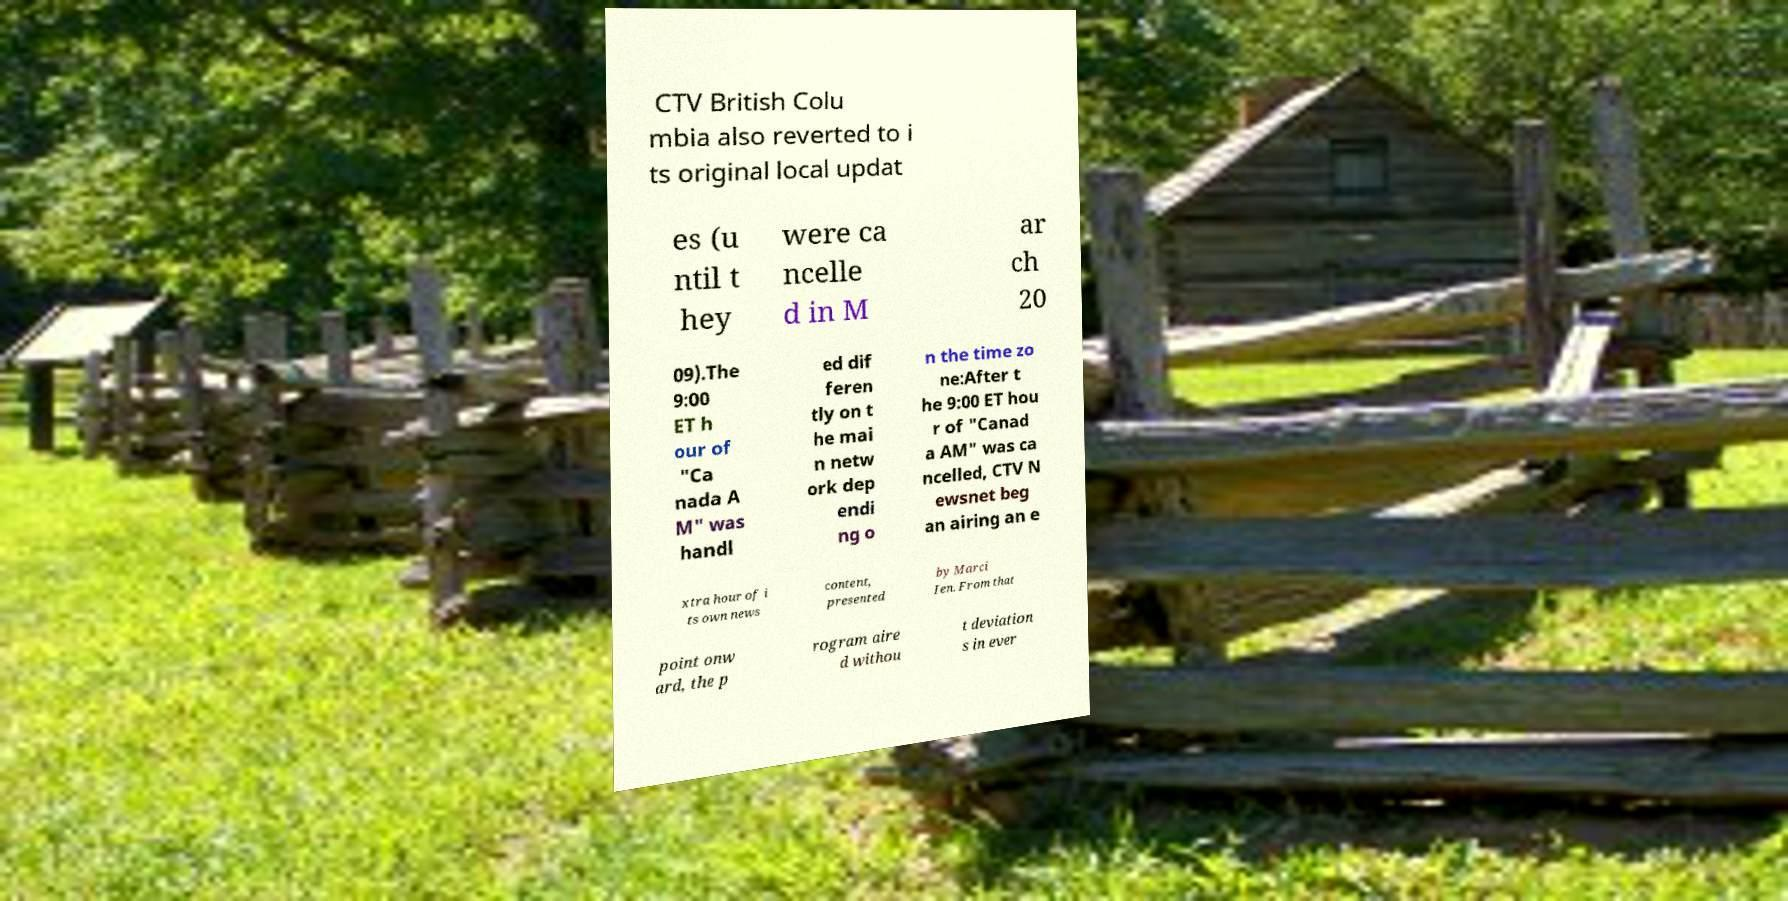Could you extract and type out the text from this image? CTV British Colu mbia also reverted to i ts original local updat es (u ntil t hey were ca ncelle d in M ar ch 20 09).The 9:00 ET h our of "Ca nada A M" was handl ed dif feren tly on t he mai n netw ork dep endi ng o n the time zo ne:After t he 9:00 ET hou r of "Canad a AM" was ca ncelled, CTV N ewsnet beg an airing an e xtra hour of i ts own news content, presented by Marci Ien. From that point onw ard, the p rogram aire d withou t deviation s in ever 